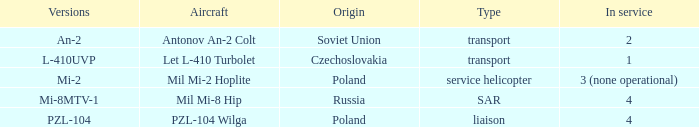Tell me the service for versions l-410uvp 1.0. 